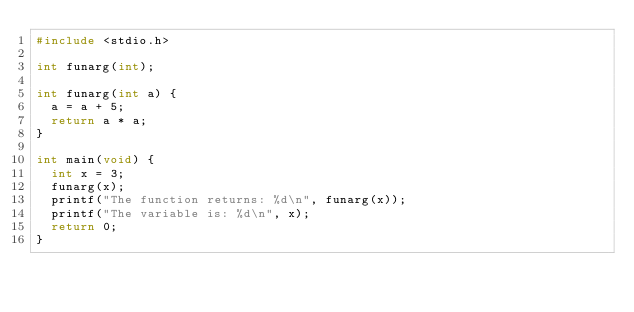<code> <loc_0><loc_0><loc_500><loc_500><_C_>#include <stdio.h>

int funarg(int);

int funarg(int a) {
  a = a + 5;
  return a * a;
}

int main(void) {
  int x = 3;
  funarg(x);
  printf("The function returns: %d\n", funarg(x));
  printf("The variable is: %d\n", x);
  return 0;
}
</code> 